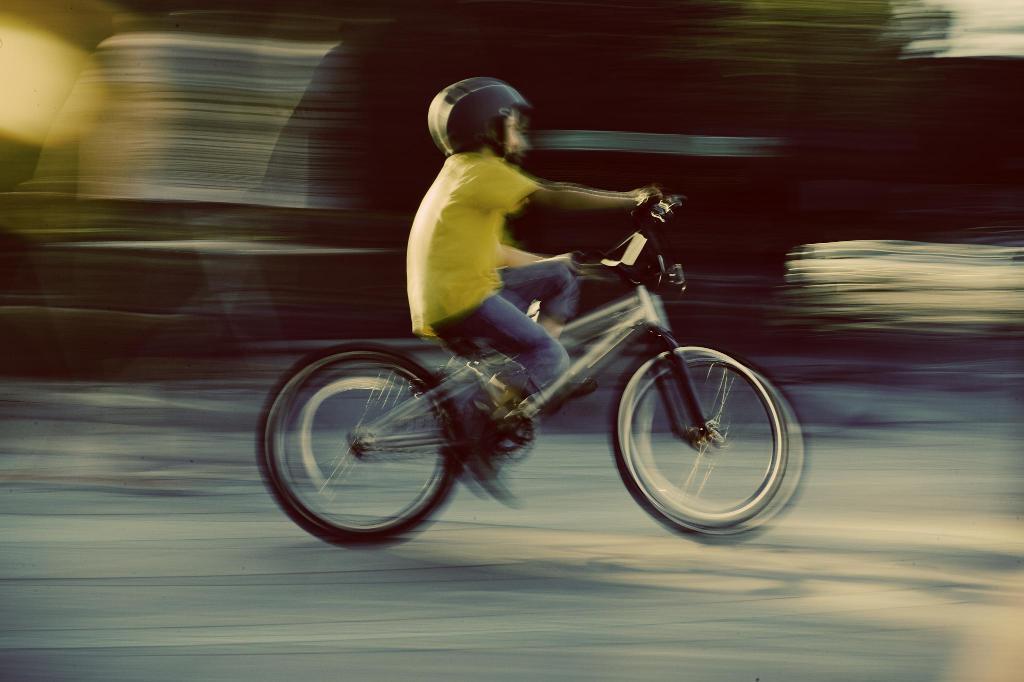Could you give a brief overview of what you see in this image? In this image I can see a person riding a bicycle on the road towards the right side. The background is blurred. 